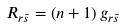<formula> <loc_0><loc_0><loc_500><loc_500>R _ { r \bar { s } } = \left ( n + 1 \right ) g _ { r \bar { s } }</formula> 